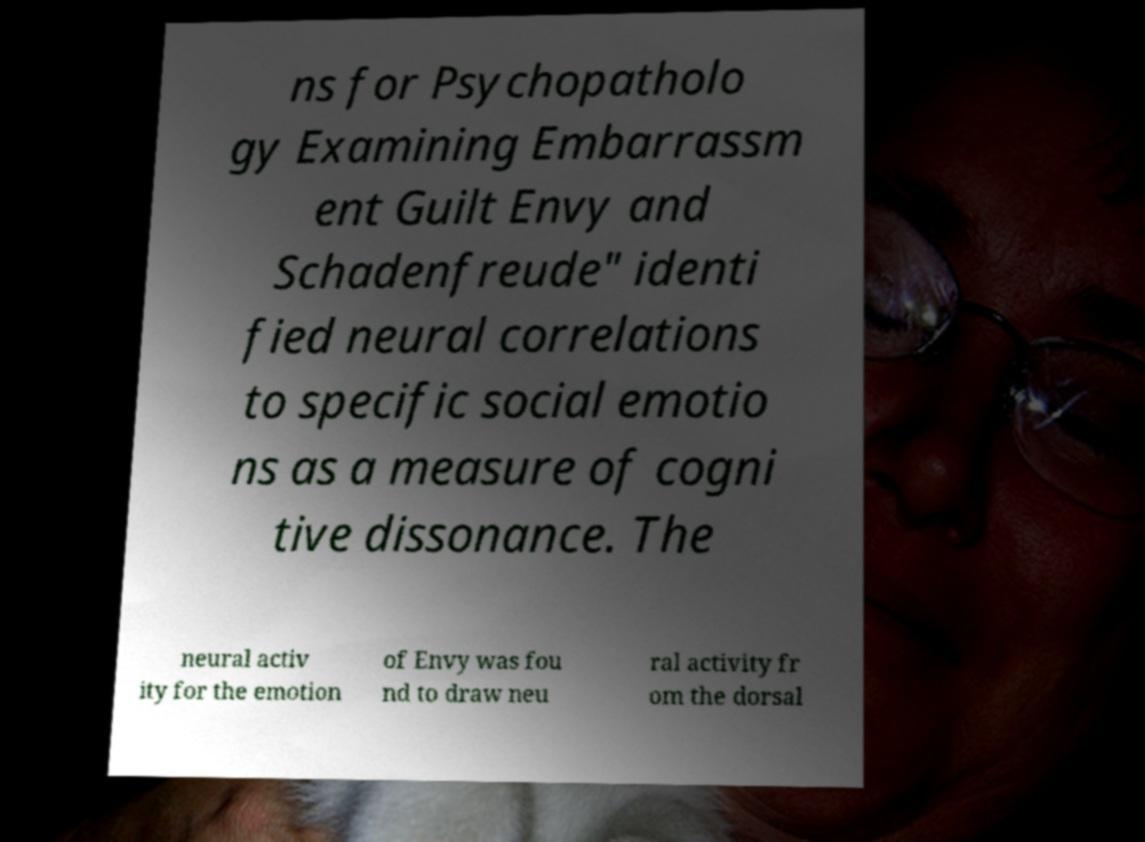Could you extract and type out the text from this image? ns for Psychopatholo gy Examining Embarrassm ent Guilt Envy and Schadenfreude" identi fied neural correlations to specific social emotio ns as a measure of cogni tive dissonance. The neural activ ity for the emotion of Envy was fou nd to draw neu ral activity fr om the dorsal 